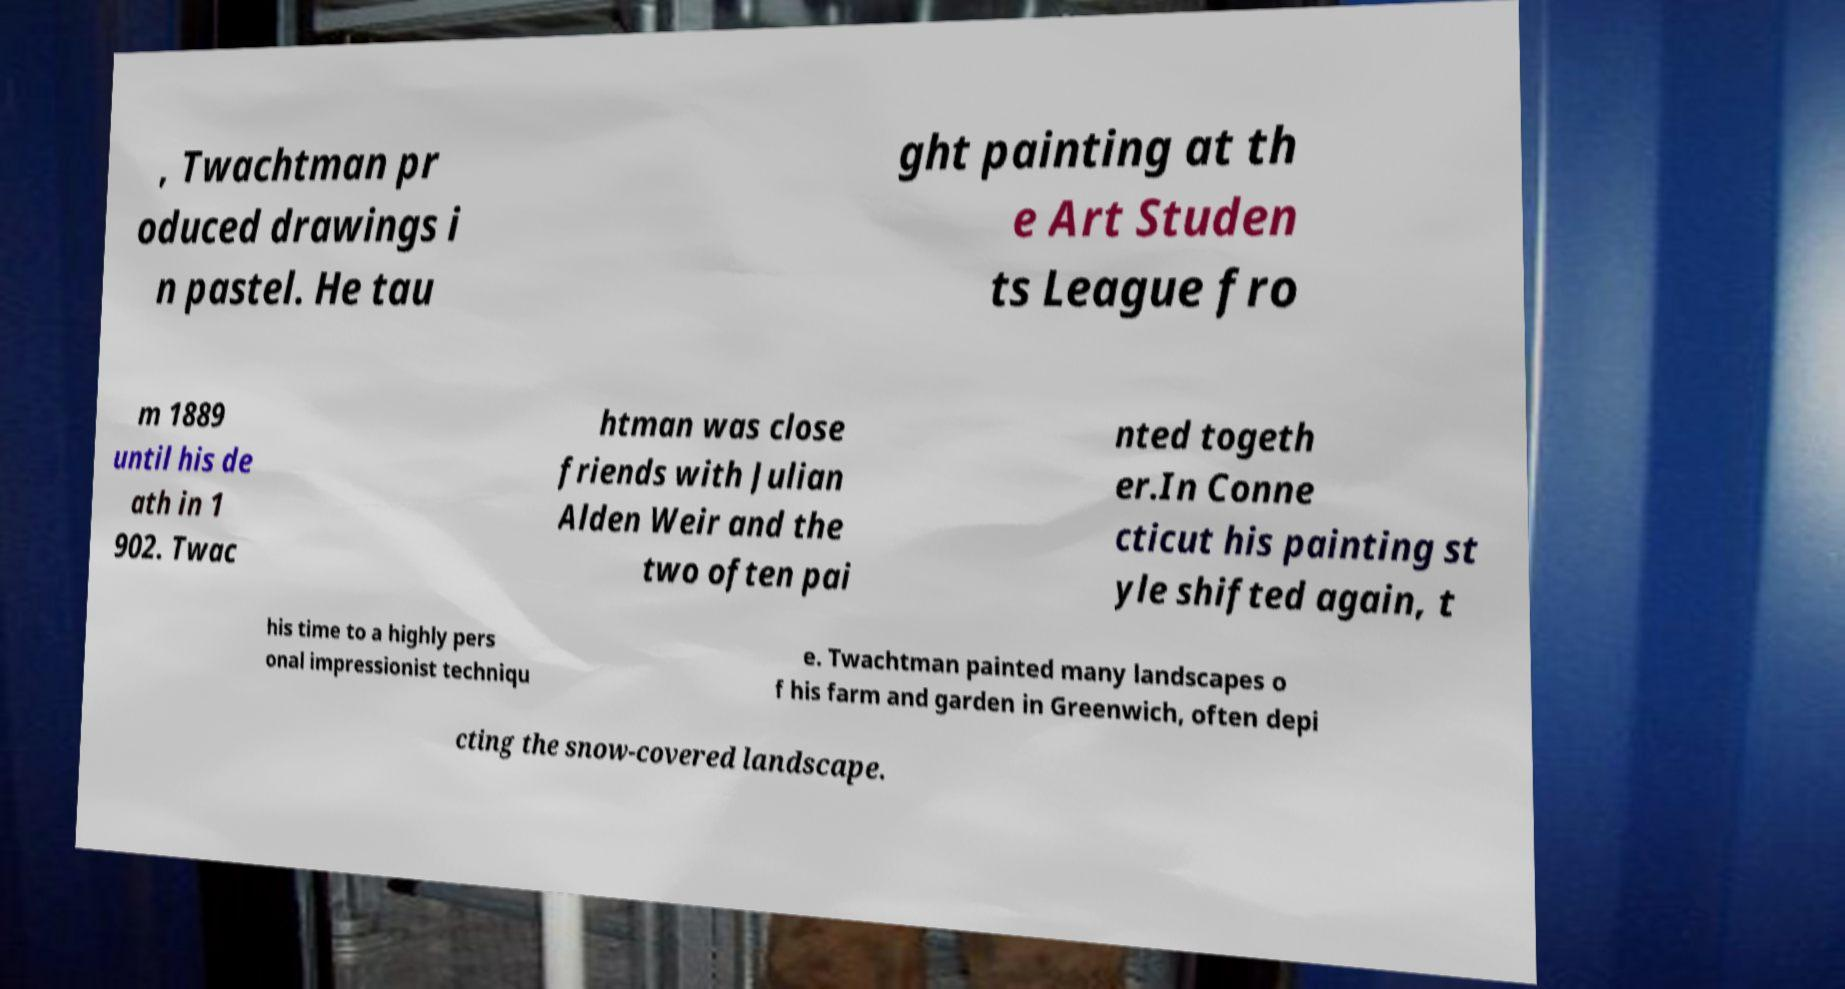Can you accurately transcribe the text from the provided image for me? , Twachtman pr oduced drawings i n pastel. He tau ght painting at th e Art Studen ts League fro m 1889 until his de ath in 1 902. Twac htman was close friends with Julian Alden Weir and the two often pai nted togeth er.In Conne cticut his painting st yle shifted again, t his time to a highly pers onal impressionist techniqu e. Twachtman painted many landscapes o f his farm and garden in Greenwich, often depi cting the snow-covered landscape. 